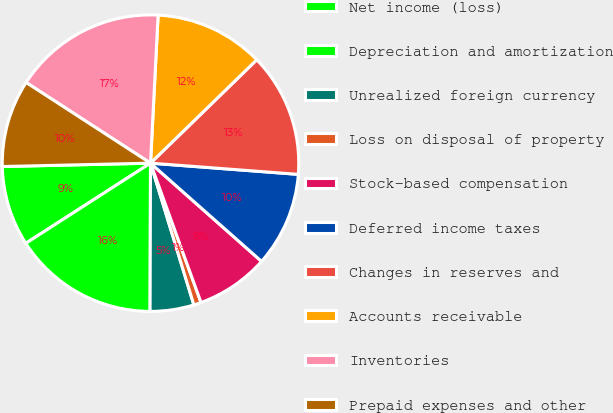Convert chart. <chart><loc_0><loc_0><loc_500><loc_500><pie_chart><fcel>Net income (loss)<fcel>Depreciation and amortization<fcel>Unrealized foreign currency<fcel>Loss on disposal of property<fcel>Stock-based compensation<fcel>Deferred income taxes<fcel>Changes in reserves and<fcel>Accounts receivable<fcel>Inventories<fcel>Prepaid expenses and other<nl><fcel>8.73%<fcel>15.86%<fcel>4.77%<fcel>0.81%<fcel>7.94%<fcel>10.32%<fcel>13.49%<fcel>11.9%<fcel>16.66%<fcel>9.52%<nl></chart> 